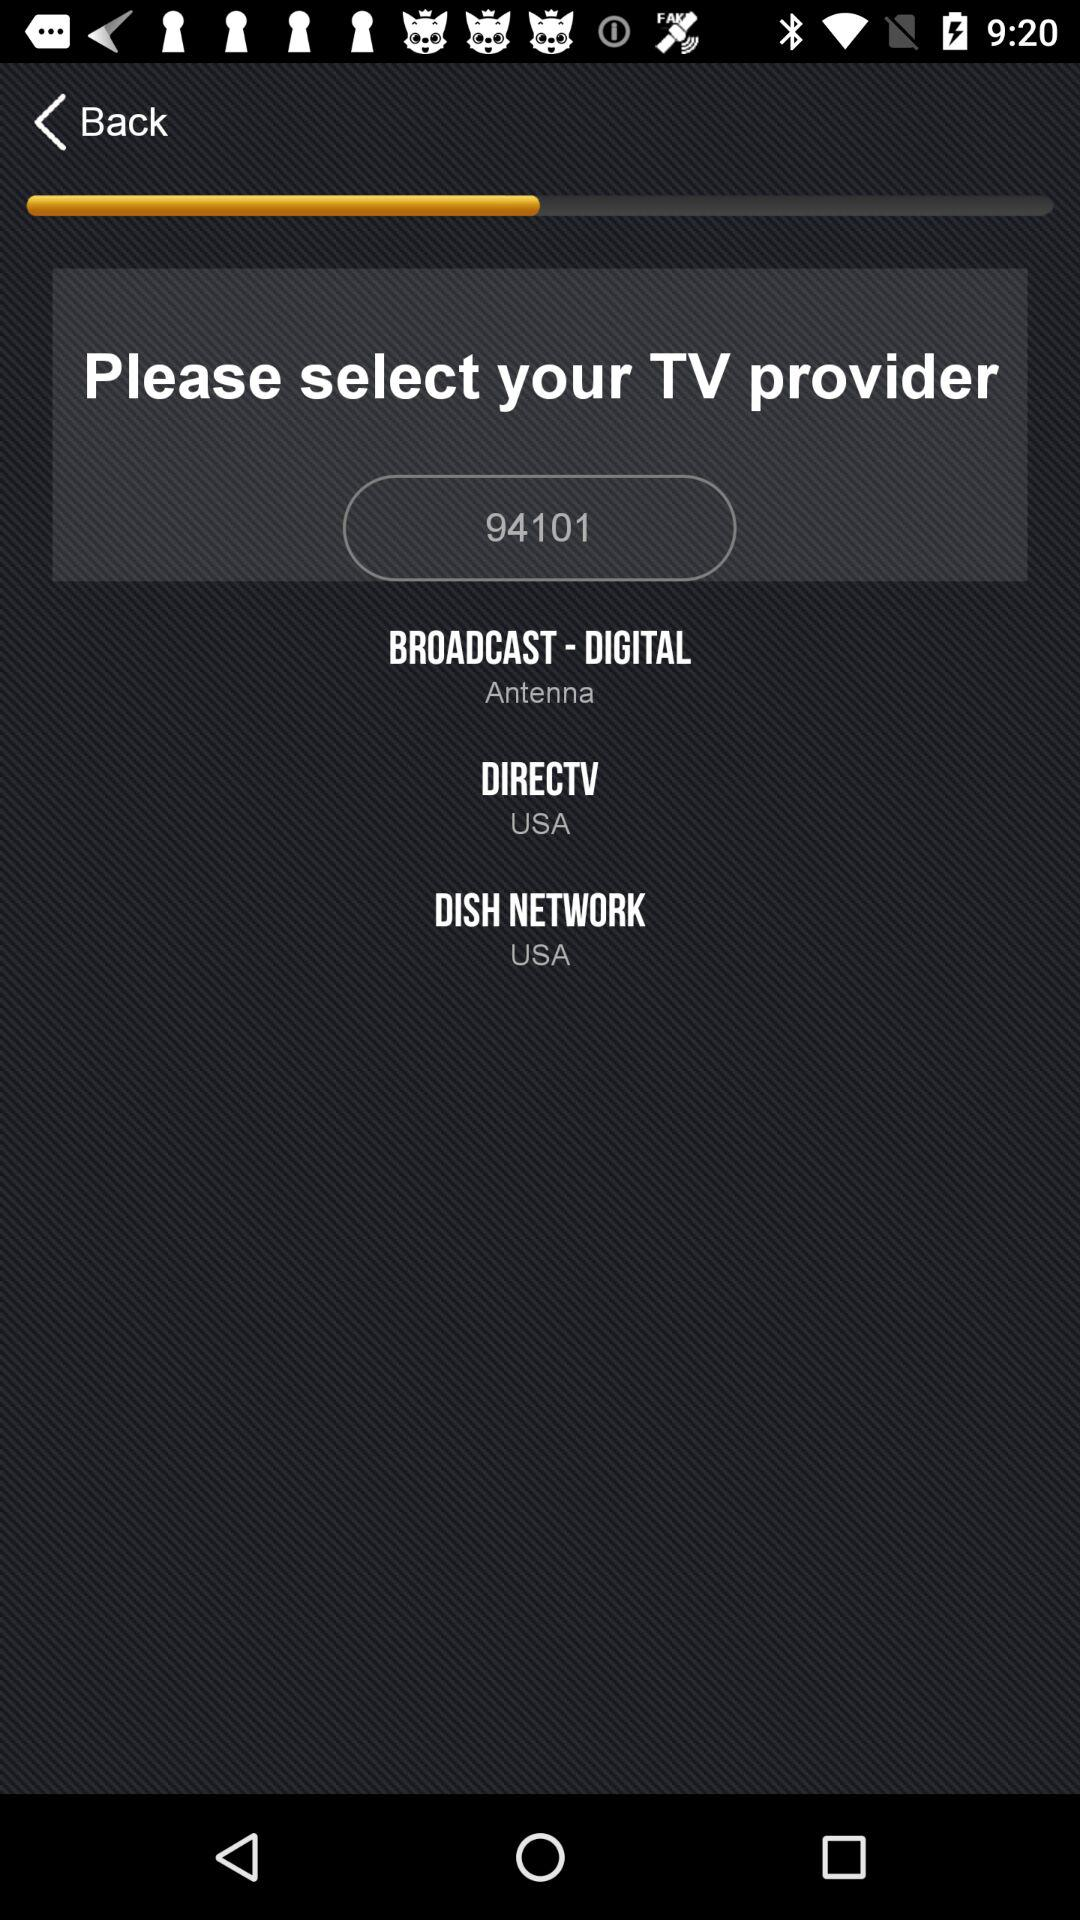How many TV providers are there?
Answer the question using a single word or phrase. 3 